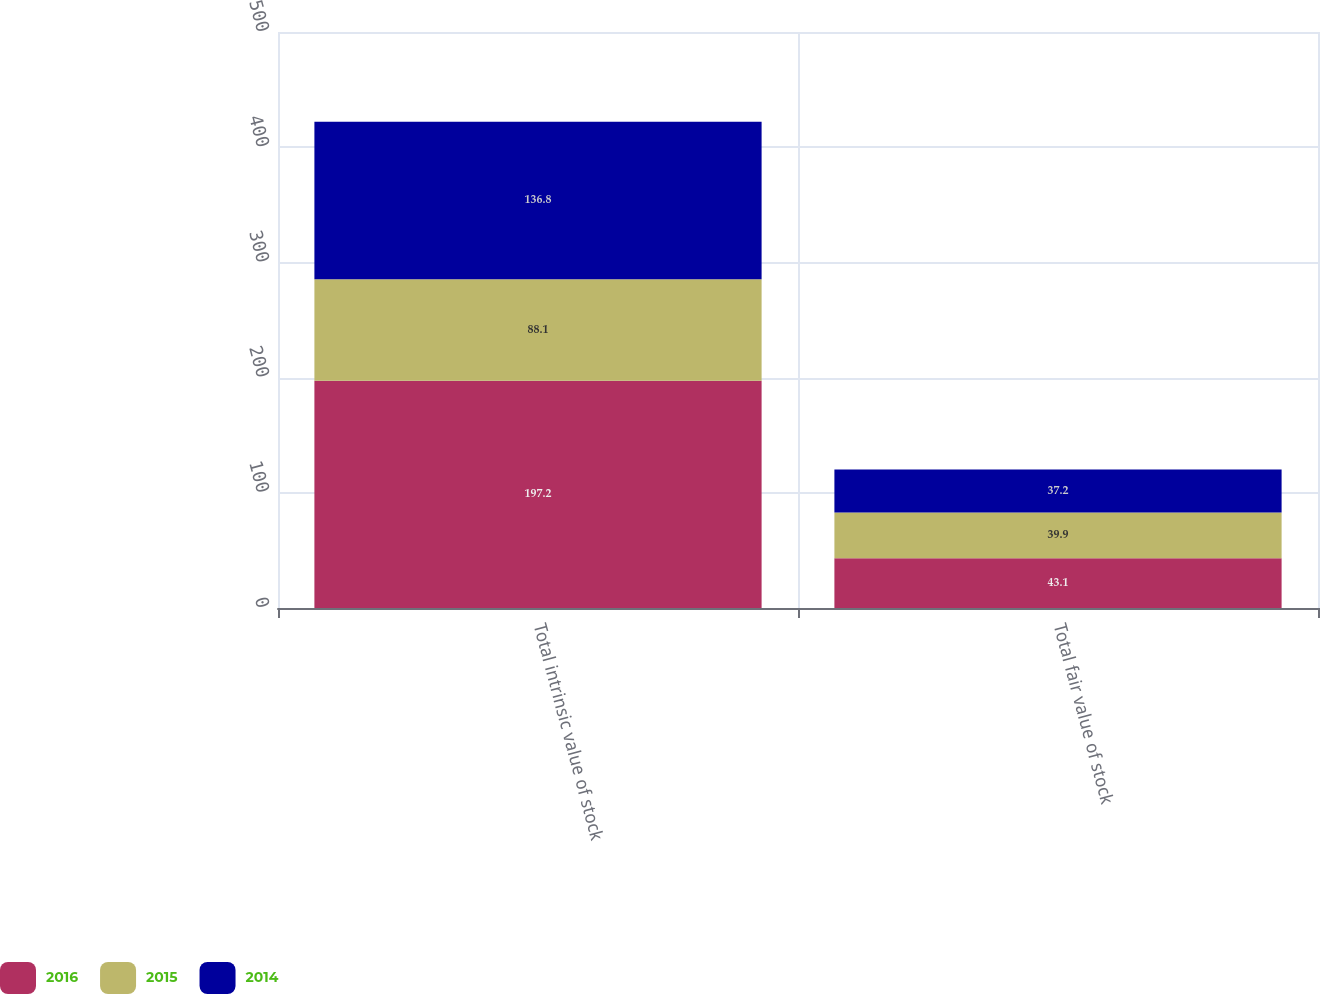Convert chart to OTSL. <chart><loc_0><loc_0><loc_500><loc_500><stacked_bar_chart><ecel><fcel>Total intrinsic value of stock<fcel>Total fair value of stock<nl><fcel>2016<fcel>197.2<fcel>43.1<nl><fcel>2015<fcel>88.1<fcel>39.9<nl><fcel>2014<fcel>136.8<fcel>37.2<nl></chart> 